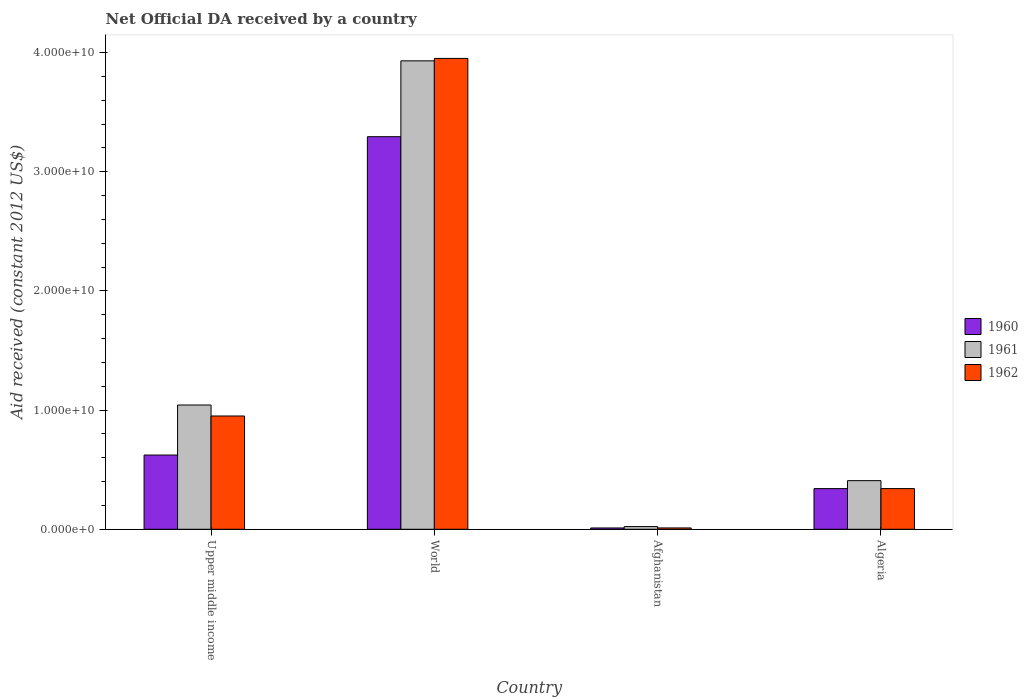How many groups of bars are there?
Offer a terse response. 4. Are the number of bars on each tick of the X-axis equal?
Keep it short and to the point. Yes. What is the label of the 4th group of bars from the left?
Offer a very short reply. Algeria. What is the net official development assistance aid received in 1960 in Algeria?
Make the answer very short. 3.41e+09. Across all countries, what is the maximum net official development assistance aid received in 1962?
Keep it short and to the point. 3.95e+1. Across all countries, what is the minimum net official development assistance aid received in 1961?
Provide a short and direct response. 2.26e+08. In which country was the net official development assistance aid received in 1960 maximum?
Make the answer very short. World. In which country was the net official development assistance aid received in 1960 minimum?
Offer a very short reply. Afghanistan. What is the total net official development assistance aid received in 1960 in the graph?
Provide a short and direct response. 4.27e+1. What is the difference between the net official development assistance aid received in 1961 in Afghanistan and that in Algeria?
Give a very brief answer. -3.85e+09. What is the difference between the net official development assistance aid received in 1961 in Upper middle income and the net official development assistance aid received in 1960 in World?
Provide a short and direct response. -2.25e+1. What is the average net official development assistance aid received in 1961 per country?
Provide a succinct answer. 1.35e+1. What is the difference between the net official development assistance aid received of/in 1960 and net official development assistance aid received of/in 1962 in Afghanistan?
Make the answer very short. -2.63e+06. In how many countries, is the net official development assistance aid received in 1961 greater than 2000000000 US$?
Keep it short and to the point. 3. What is the ratio of the net official development assistance aid received in 1962 in Afghanistan to that in World?
Your response must be concise. 0. Is the net official development assistance aid received in 1961 in Algeria less than that in Upper middle income?
Ensure brevity in your answer.  Yes. What is the difference between the highest and the second highest net official development assistance aid received in 1961?
Ensure brevity in your answer.  2.89e+1. What is the difference between the highest and the lowest net official development assistance aid received in 1961?
Give a very brief answer. 3.91e+1. Is the sum of the net official development assistance aid received in 1960 in Afghanistan and Upper middle income greater than the maximum net official development assistance aid received in 1961 across all countries?
Your answer should be very brief. No. What does the 3rd bar from the right in World represents?
Keep it short and to the point. 1960. How many countries are there in the graph?
Keep it short and to the point. 4. What is the difference between two consecutive major ticks on the Y-axis?
Provide a short and direct response. 1.00e+1. Are the values on the major ticks of Y-axis written in scientific E-notation?
Your answer should be compact. Yes. Does the graph contain any zero values?
Offer a very short reply. No. Does the graph contain grids?
Your answer should be very brief. No. Where does the legend appear in the graph?
Make the answer very short. Center right. How many legend labels are there?
Offer a terse response. 3. How are the legend labels stacked?
Your answer should be very brief. Vertical. What is the title of the graph?
Keep it short and to the point. Net Official DA received by a country. Does "1999" appear as one of the legend labels in the graph?
Make the answer very short. No. What is the label or title of the Y-axis?
Your answer should be compact. Aid received (constant 2012 US$). What is the Aid received (constant 2012 US$) in 1960 in Upper middle income?
Your answer should be very brief. 6.23e+09. What is the Aid received (constant 2012 US$) in 1961 in Upper middle income?
Make the answer very short. 1.04e+1. What is the Aid received (constant 2012 US$) of 1962 in Upper middle income?
Ensure brevity in your answer.  9.51e+09. What is the Aid received (constant 2012 US$) of 1960 in World?
Your answer should be compact. 3.29e+1. What is the Aid received (constant 2012 US$) in 1961 in World?
Give a very brief answer. 3.93e+1. What is the Aid received (constant 2012 US$) of 1962 in World?
Provide a succinct answer. 3.95e+1. What is the Aid received (constant 2012 US$) in 1960 in Afghanistan?
Your response must be concise. 1.10e+08. What is the Aid received (constant 2012 US$) of 1961 in Afghanistan?
Ensure brevity in your answer.  2.26e+08. What is the Aid received (constant 2012 US$) of 1962 in Afghanistan?
Keep it short and to the point. 1.12e+08. What is the Aid received (constant 2012 US$) of 1960 in Algeria?
Provide a succinct answer. 3.41e+09. What is the Aid received (constant 2012 US$) in 1961 in Algeria?
Your answer should be very brief. 4.08e+09. What is the Aid received (constant 2012 US$) in 1962 in Algeria?
Give a very brief answer. 3.41e+09. Across all countries, what is the maximum Aid received (constant 2012 US$) of 1960?
Provide a short and direct response. 3.29e+1. Across all countries, what is the maximum Aid received (constant 2012 US$) of 1961?
Your response must be concise. 3.93e+1. Across all countries, what is the maximum Aid received (constant 2012 US$) in 1962?
Ensure brevity in your answer.  3.95e+1. Across all countries, what is the minimum Aid received (constant 2012 US$) in 1960?
Your answer should be very brief. 1.10e+08. Across all countries, what is the minimum Aid received (constant 2012 US$) of 1961?
Ensure brevity in your answer.  2.26e+08. Across all countries, what is the minimum Aid received (constant 2012 US$) of 1962?
Make the answer very short. 1.12e+08. What is the total Aid received (constant 2012 US$) of 1960 in the graph?
Your answer should be very brief. 4.27e+1. What is the total Aid received (constant 2012 US$) in 1961 in the graph?
Your answer should be very brief. 5.40e+1. What is the total Aid received (constant 2012 US$) of 1962 in the graph?
Your answer should be very brief. 5.25e+1. What is the difference between the Aid received (constant 2012 US$) in 1960 in Upper middle income and that in World?
Offer a terse response. -2.67e+1. What is the difference between the Aid received (constant 2012 US$) in 1961 in Upper middle income and that in World?
Provide a succinct answer. -2.89e+1. What is the difference between the Aid received (constant 2012 US$) in 1962 in Upper middle income and that in World?
Keep it short and to the point. -3.00e+1. What is the difference between the Aid received (constant 2012 US$) in 1960 in Upper middle income and that in Afghanistan?
Provide a short and direct response. 6.12e+09. What is the difference between the Aid received (constant 2012 US$) in 1961 in Upper middle income and that in Afghanistan?
Offer a terse response. 1.02e+1. What is the difference between the Aid received (constant 2012 US$) of 1962 in Upper middle income and that in Afghanistan?
Ensure brevity in your answer.  9.39e+09. What is the difference between the Aid received (constant 2012 US$) in 1960 in Upper middle income and that in Algeria?
Your answer should be very brief. 2.82e+09. What is the difference between the Aid received (constant 2012 US$) in 1961 in Upper middle income and that in Algeria?
Give a very brief answer. 6.35e+09. What is the difference between the Aid received (constant 2012 US$) in 1962 in Upper middle income and that in Algeria?
Keep it short and to the point. 6.09e+09. What is the difference between the Aid received (constant 2012 US$) of 1960 in World and that in Afghanistan?
Your answer should be compact. 3.28e+1. What is the difference between the Aid received (constant 2012 US$) of 1961 in World and that in Afghanistan?
Offer a very short reply. 3.91e+1. What is the difference between the Aid received (constant 2012 US$) of 1962 in World and that in Afghanistan?
Your answer should be compact. 3.94e+1. What is the difference between the Aid received (constant 2012 US$) in 1960 in World and that in Algeria?
Offer a terse response. 2.95e+1. What is the difference between the Aid received (constant 2012 US$) of 1961 in World and that in Algeria?
Provide a succinct answer. 3.52e+1. What is the difference between the Aid received (constant 2012 US$) in 1962 in World and that in Algeria?
Your answer should be compact. 3.61e+1. What is the difference between the Aid received (constant 2012 US$) of 1960 in Afghanistan and that in Algeria?
Offer a terse response. -3.30e+09. What is the difference between the Aid received (constant 2012 US$) in 1961 in Afghanistan and that in Algeria?
Offer a terse response. -3.85e+09. What is the difference between the Aid received (constant 2012 US$) in 1962 in Afghanistan and that in Algeria?
Your response must be concise. -3.30e+09. What is the difference between the Aid received (constant 2012 US$) in 1960 in Upper middle income and the Aid received (constant 2012 US$) in 1961 in World?
Offer a terse response. -3.31e+1. What is the difference between the Aid received (constant 2012 US$) of 1960 in Upper middle income and the Aid received (constant 2012 US$) of 1962 in World?
Make the answer very short. -3.33e+1. What is the difference between the Aid received (constant 2012 US$) in 1961 in Upper middle income and the Aid received (constant 2012 US$) in 1962 in World?
Your answer should be compact. -2.91e+1. What is the difference between the Aid received (constant 2012 US$) of 1960 in Upper middle income and the Aid received (constant 2012 US$) of 1961 in Afghanistan?
Keep it short and to the point. 6.00e+09. What is the difference between the Aid received (constant 2012 US$) in 1960 in Upper middle income and the Aid received (constant 2012 US$) in 1962 in Afghanistan?
Give a very brief answer. 6.12e+09. What is the difference between the Aid received (constant 2012 US$) of 1961 in Upper middle income and the Aid received (constant 2012 US$) of 1962 in Afghanistan?
Your response must be concise. 1.03e+1. What is the difference between the Aid received (constant 2012 US$) in 1960 in Upper middle income and the Aid received (constant 2012 US$) in 1961 in Algeria?
Your response must be concise. 2.15e+09. What is the difference between the Aid received (constant 2012 US$) of 1960 in Upper middle income and the Aid received (constant 2012 US$) of 1962 in Algeria?
Provide a succinct answer. 2.82e+09. What is the difference between the Aid received (constant 2012 US$) of 1961 in Upper middle income and the Aid received (constant 2012 US$) of 1962 in Algeria?
Provide a short and direct response. 7.01e+09. What is the difference between the Aid received (constant 2012 US$) of 1960 in World and the Aid received (constant 2012 US$) of 1961 in Afghanistan?
Provide a short and direct response. 3.27e+1. What is the difference between the Aid received (constant 2012 US$) of 1960 in World and the Aid received (constant 2012 US$) of 1962 in Afghanistan?
Offer a very short reply. 3.28e+1. What is the difference between the Aid received (constant 2012 US$) in 1961 in World and the Aid received (constant 2012 US$) in 1962 in Afghanistan?
Keep it short and to the point. 3.92e+1. What is the difference between the Aid received (constant 2012 US$) in 1960 in World and the Aid received (constant 2012 US$) in 1961 in Algeria?
Your answer should be compact. 2.89e+1. What is the difference between the Aid received (constant 2012 US$) of 1960 in World and the Aid received (constant 2012 US$) of 1962 in Algeria?
Offer a very short reply. 2.95e+1. What is the difference between the Aid received (constant 2012 US$) of 1961 in World and the Aid received (constant 2012 US$) of 1962 in Algeria?
Your response must be concise. 3.59e+1. What is the difference between the Aid received (constant 2012 US$) in 1960 in Afghanistan and the Aid received (constant 2012 US$) in 1961 in Algeria?
Provide a succinct answer. -3.97e+09. What is the difference between the Aid received (constant 2012 US$) of 1960 in Afghanistan and the Aid received (constant 2012 US$) of 1962 in Algeria?
Offer a terse response. -3.30e+09. What is the difference between the Aid received (constant 2012 US$) of 1961 in Afghanistan and the Aid received (constant 2012 US$) of 1962 in Algeria?
Keep it short and to the point. -3.19e+09. What is the average Aid received (constant 2012 US$) in 1960 per country?
Offer a very short reply. 1.07e+1. What is the average Aid received (constant 2012 US$) of 1961 per country?
Provide a succinct answer. 1.35e+1. What is the average Aid received (constant 2012 US$) in 1962 per country?
Your answer should be compact. 1.31e+1. What is the difference between the Aid received (constant 2012 US$) in 1960 and Aid received (constant 2012 US$) in 1961 in Upper middle income?
Offer a terse response. -4.20e+09. What is the difference between the Aid received (constant 2012 US$) in 1960 and Aid received (constant 2012 US$) in 1962 in Upper middle income?
Your response must be concise. -3.28e+09. What is the difference between the Aid received (constant 2012 US$) in 1961 and Aid received (constant 2012 US$) in 1962 in Upper middle income?
Give a very brief answer. 9.22e+08. What is the difference between the Aid received (constant 2012 US$) of 1960 and Aid received (constant 2012 US$) of 1961 in World?
Offer a very short reply. -6.36e+09. What is the difference between the Aid received (constant 2012 US$) of 1960 and Aid received (constant 2012 US$) of 1962 in World?
Make the answer very short. -6.57e+09. What is the difference between the Aid received (constant 2012 US$) of 1961 and Aid received (constant 2012 US$) of 1962 in World?
Your response must be concise. -2.05e+08. What is the difference between the Aid received (constant 2012 US$) in 1960 and Aid received (constant 2012 US$) in 1961 in Afghanistan?
Your answer should be compact. -1.16e+08. What is the difference between the Aid received (constant 2012 US$) in 1960 and Aid received (constant 2012 US$) in 1962 in Afghanistan?
Your answer should be very brief. -2.63e+06. What is the difference between the Aid received (constant 2012 US$) in 1961 and Aid received (constant 2012 US$) in 1962 in Afghanistan?
Provide a succinct answer. 1.13e+08. What is the difference between the Aid received (constant 2012 US$) of 1960 and Aid received (constant 2012 US$) of 1961 in Algeria?
Provide a short and direct response. -6.69e+08. What is the difference between the Aid received (constant 2012 US$) of 1960 and Aid received (constant 2012 US$) of 1962 in Algeria?
Your response must be concise. -2.85e+06. What is the difference between the Aid received (constant 2012 US$) in 1961 and Aid received (constant 2012 US$) in 1962 in Algeria?
Your answer should be very brief. 6.66e+08. What is the ratio of the Aid received (constant 2012 US$) of 1960 in Upper middle income to that in World?
Your answer should be very brief. 0.19. What is the ratio of the Aid received (constant 2012 US$) of 1961 in Upper middle income to that in World?
Give a very brief answer. 0.27. What is the ratio of the Aid received (constant 2012 US$) of 1962 in Upper middle income to that in World?
Provide a short and direct response. 0.24. What is the ratio of the Aid received (constant 2012 US$) in 1960 in Upper middle income to that in Afghanistan?
Your answer should be compact. 56.73. What is the ratio of the Aid received (constant 2012 US$) in 1961 in Upper middle income to that in Afghanistan?
Keep it short and to the point. 46.2. What is the ratio of the Aid received (constant 2012 US$) of 1962 in Upper middle income to that in Afghanistan?
Keep it short and to the point. 84.54. What is the ratio of the Aid received (constant 2012 US$) of 1960 in Upper middle income to that in Algeria?
Give a very brief answer. 1.83. What is the ratio of the Aid received (constant 2012 US$) of 1961 in Upper middle income to that in Algeria?
Make the answer very short. 2.56. What is the ratio of the Aid received (constant 2012 US$) of 1962 in Upper middle income to that in Algeria?
Your answer should be compact. 2.78. What is the ratio of the Aid received (constant 2012 US$) of 1960 in World to that in Afghanistan?
Make the answer very short. 300.02. What is the ratio of the Aid received (constant 2012 US$) in 1961 in World to that in Afghanistan?
Ensure brevity in your answer.  174.12. What is the ratio of the Aid received (constant 2012 US$) of 1962 in World to that in Afghanistan?
Make the answer very short. 351.41. What is the ratio of the Aid received (constant 2012 US$) of 1960 in World to that in Algeria?
Offer a terse response. 9.66. What is the ratio of the Aid received (constant 2012 US$) of 1961 in World to that in Algeria?
Your answer should be very brief. 9.63. What is the ratio of the Aid received (constant 2012 US$) in 1962 in World to that in Algeria?
Make the answer very short. 11.57. What is the ratio of the Aid received (constant 2012 US$) in 1960 in Afghanistan to that in Algeria?
Your response must be concise. 0.03. What is the ratio of the Aid received (constant 2012 US$) of 1961 in Afghanistan to that in Algeria?
Make the answer very short. 0.06. What is the ratio of the Aid received (constant 2012 US$) of 1962 in Afghanistan to that in Algeria?
Provide a short and direct response. 0.03. What is the difference between the highest and the second highest Aid received (constant 2012 US$) of 1960?
Keep it short and to the point. 2.67e+1. What is the difference between the highest and the second highest Aid received (constant 2012 US$) in 1961?
Offer a terse response. 2.89e+1. What is the difference between the highest and the second highest Aid received (constant 2012 US$) of 1962?
Your response must be concise. 3.00e+1. What is the difference between the highest and the lowest Aid received (constant 2012 US$) of 1960?
Ensure brevity in your answer.  3.28e+1. What is the difference between the highest and the lowest Aid received (constant 2012 US$) of 1961?
Your answer should be very brief. 3.91e+1. What is the difference between the highest and the lowest Aid received (constant 2012 US$) in 1962?
Make the answer very short. 3.94e+1. 